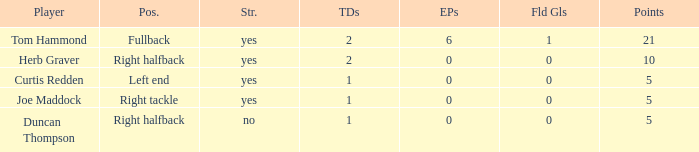Name the most extra points for right tackle 0.0. 